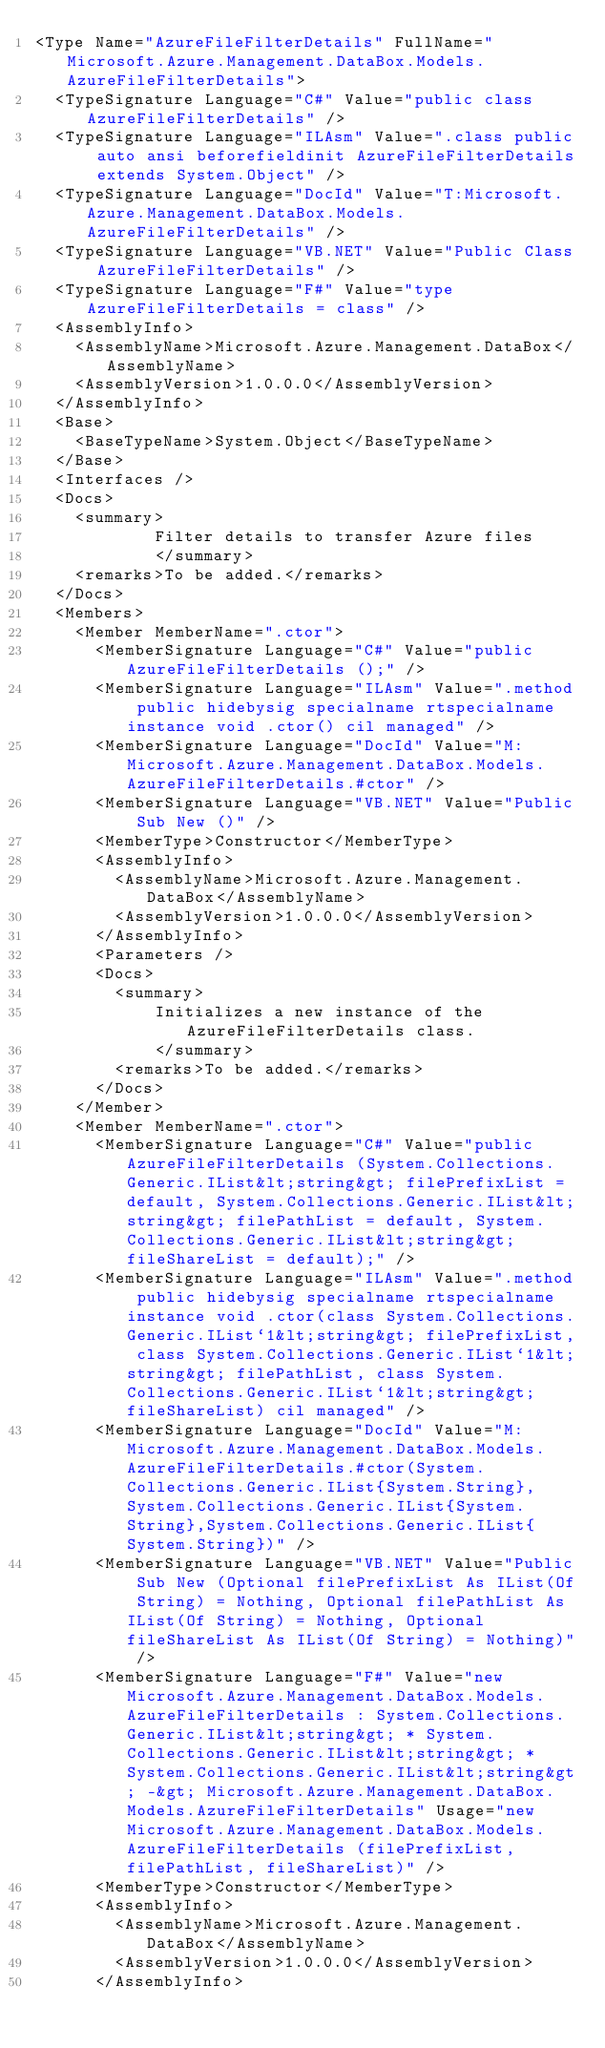Convert code to text. <code><loc_0><loc_0><loc_500><loc_500><_XML_><Type Name="AzureFileFilterDetails" FullName="Microsoft.Azure.Management.DataBox.Models.AzureFileFilterDetails">
  <TypeSignature Language="C#" Value="public class AzureFileFilterDetails" />
  <TypeSignature Language="ILAsm" Value=".class public auto ansi beforefieldinit AzureFileFilterDetails extends System.Object" />
  <TypeSignature Language="DocId" Value="T:Microsoft.Azure.Management.DataBox.Models.AzureFileFilterDetails" />
  <TypeSignature Language="VB.NET" Value="Public Class AzureFileFilterDetails" />
  <TypeSignature Language="F#" Value="type AzureFileFilterDetails = class" />
  <AssemblyInfo>
    <AssemblyName>Microsoft.Azure.Management.DataBox</AssemblyName>
    <AssemblyVersion>1.0.0.0</AssemblyVersion>
  </AssemblyInfo>
  <Base>
    <BaseTypeName>System.Object</BaseTypeName>
  </Base>
  <Interfaces />
  <Docs>
    <summary>
            Filter details to transfer Azure files
            </summary>
    <remarks>To be added.</remarks>
  </Docs>
  <Members>
    <Member MemberName=".ctor">
      <MemberSignature Language="C#" Value="public AzureFileFilterDetails ();" />
      <MemberSignature Language="ILAsm" Value=".method public hidebysig specialname rtspecialname instance void .ctor() cil managed" />
      <MemberSignature Language="DocId" Value="M:Microsoft.Azure.Management.DataBox.Models.AzureFileFilterDetails.#ctor" />
      <MemberSignature Language="VB.NET" Value="Public Sub New ()" />
      <MemberType>Constructor</MemberType>
      <AssemblyInfo>
        <AssemblyName>Microsoft.Azure.Management.DataBox</AssemblyName>
        <AssemblyVersion>1.0.0.0</AssemblyVersion>
      </AssemblyInfo>
      <Parameters />
      <Docs>
        <summary>
            Initializes a new instance of the AzureFileFilterDetails class.
            </summary>
        <remarks>To be added.</remarks>
      </Docs>
    </Member>
    <Member MemberName=".ctor">
      <MemberSignature Language="C#" Value="public AzureFileFilterDetails (System.Collections.Generic.IList&lt;string&gt; filePrefixList = default, System.Collections.Generic.IList&lt;string&gt; filePathList = default, System.Collections.Generic.IList&lt;string&gt; fileShareList = default);" />
      <MemberSignature Language="ILAsm" Value=".method public hidebysig specialname rtspecialname instance void .ctor(class System.Collections.Generic.IList`1&lt;string&gt; filePrefixList, class System.Collections.Generic.IList`1&lt;string&gt; filePathList, class System.Collections.Generic.IList`1&lt;string&gt; fileShareList) cil managed" />
      <MemberSignature Language="DocId" Value="M:Microsoft.Azure.Management.DataBox.Models.AzureFileFilterDetails.#ctor(System.Collections.Generic.IList{System.String},System.Collections.Generic.IList{System.String},System.Collections.Generic.IList{System.String})" />
      <MemberSignature Language="VB.NET" Value="Public Sub New (Optional filePrefixList As IList(Of String) = Nothing, Optional filePathList As IList(Of String) = Nothing, Optional fileShareList As IList(Of String) = Nothing)" />
      <MemberSignature Language="F#" Value="new Microsoft.Azure.Management.DataBox.Models.AzureFileFilterDetails : System.Collections.Generic.IList&lt;string&gt; * System.Collections.Generic.IList&lt;string&gt; * System.Collections.Generic.IList&lt;string&gt; -&gt; Microsoft.Azure.Management.DataBox.Models.AzureFileFilterDetails" Usage="new Microsoft.Azure.Management.DataBox.Models.AzureFileFilterDetails (filePrefixList, filePathList, fileShareList)" />
      <MemberType>Constructor</MemberType>
      <AssemblyInfo>
        <AssemblyName>Microsoft.Azure.Management.DataBox</AssemblyName>
        <AssemblyVersion>1.0.0.0</AssemblyVersion>
      </AssemblyInfo></code> 